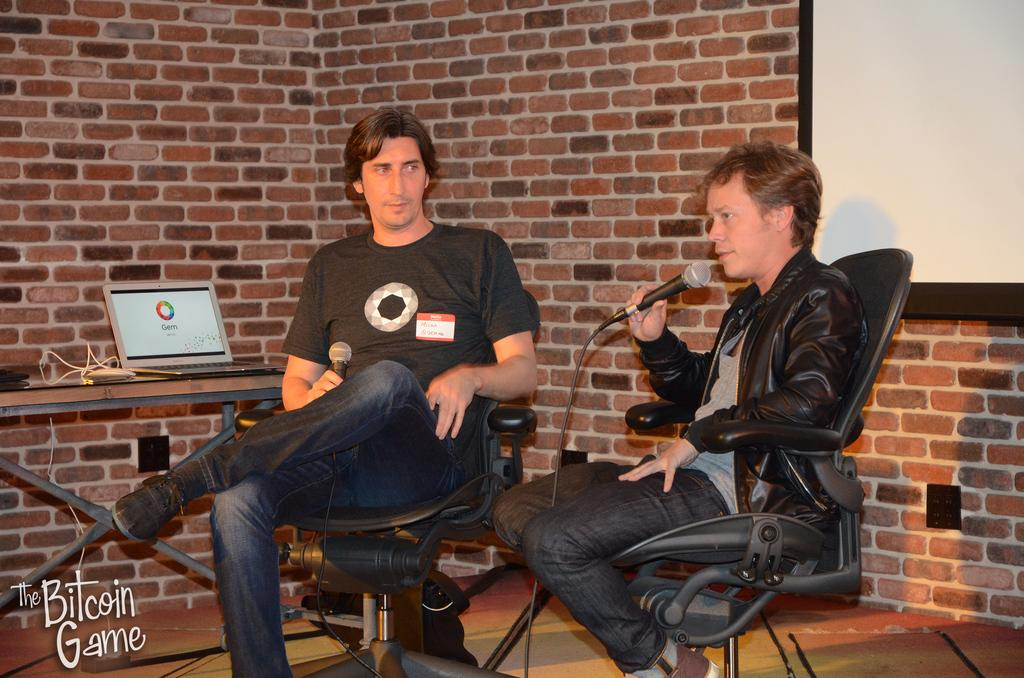How many people are in the image? There are two men in the image. What are the men doing in the image? The men are sitting on chairs and holding mics in their hands. What can be seen in the background of the image? There is a laptop and a brick wall in the background of the image. How many babies are crawling on the floor in the image? There are no babies present in the image. What type of learning material can be seen on the laptop in the image? The image does not show any learning material on the laptop; it only shows that there is a laptop in the background. 